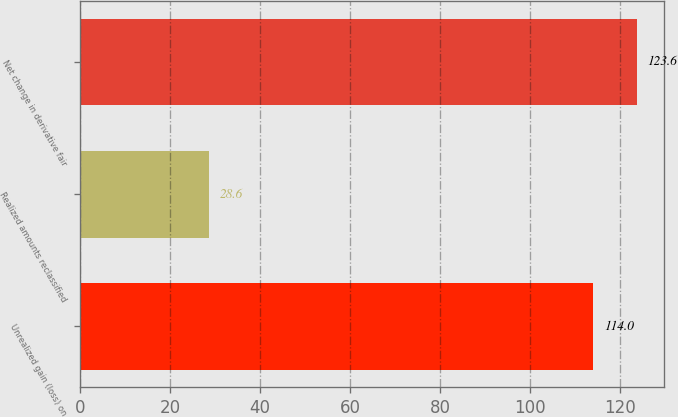<chart> <loc_0><loc_0><loc_500><loc_500><bar_chart><fcel>Unrealized gain (loss) on<fcel>Realized amounts reclassified<fcel>Net change in derivative fair<nl><fcel>114<fcel>28.6<fcel>123.6<nl></chart> 